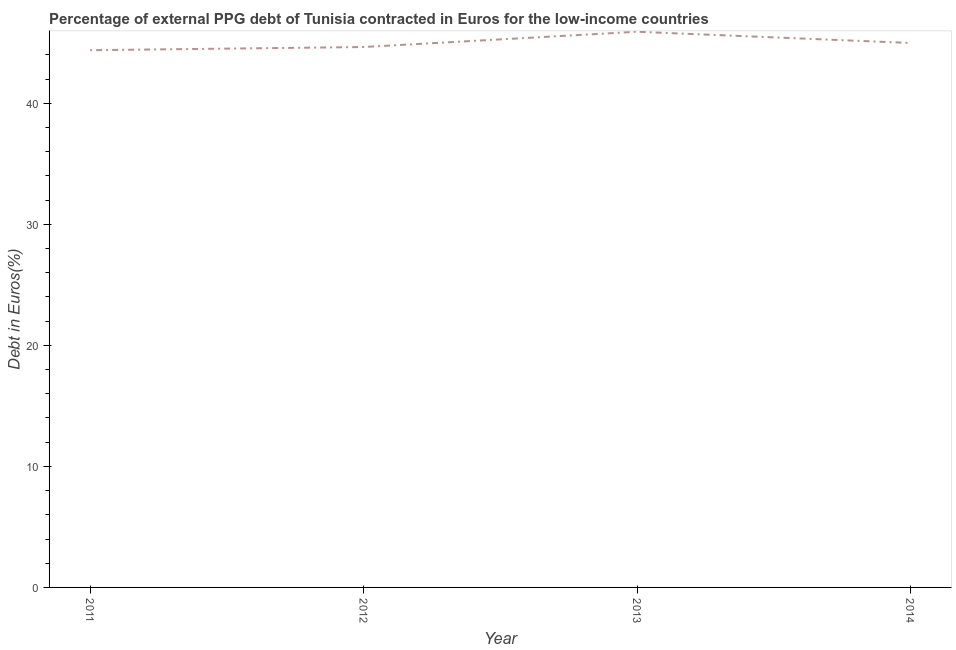What is the currency composition of ppg debt in 2014?
Offer a very short reply. 44.98. Across all years, what is the maximum currency composition of ppg debt?
Give a very brief answer. 45.91. Across all years, what is the minimum currency composition of ppg debt?
Offer a terse response. 44.39. What is the sum of the currency composition of ppg debt?
Make the answer very short. 179.93. What is the difference between the currency composition of ppg debt in 2012 and 2013?
Your answer should be very brief. -1.26. What is the average currency composition of ppg debt per year?
Offer a very short reply. 44.98. What is the median currency composition of ppg debt?
Your response must be concise. 44.82. In how many years, is the currency composition of ppg debt greater than 14 %?
Your response must be concise. 4. What is the ratio of the currency composition of ppg debt in 2012 to that in 2014?
Your answer should be very brief. 0.99. Is the currency composition of ppg debt in 2013 less than that in 2014?
Your answer should be very brief. No. Is the difference between the currency composition of ppg debt in 2012 and 2013 greater than the difference between any two years?
Keep it short and to the point. No. What is the difference between the highest and the second highest currency composition of ppg debt?
Offer a terse response. 0.93. What is the difference between the highest and the lowest currency composition of ppg debt?
Provide a short and direct response. 1.53. How many years are there in the graph?
Make the answer very short. 4. Are the values on the major ticks of Y-axis written in scientific E-notation?
Your answer should be very brief. No. Does the graph contain grids?
Ensure brevity in your answer.  No. What is the title of the graph?
Ensure brevity in your answer.  Percentage of external PPG debt of Tunisia contracted in Euros for the low-income countries. What is the label or title of the X-axis?
Give a very brief answer. Year. What is the label or title of the Y-axis?
Provide a short and direct response. Debt in Euros(%). What is the Debt in Euros(%) in 2011?
Offer a very short reply. 44.39. What is the Debt in Euros(%) of 2012?
Ensure brevity in your answer.  44.65. What is the Debt in Euros(%) of 2013?
Make the answer very short. 45.91. What is the Debt in Euros(%) of 2014?
Ensure brevity in your answer.  44.98. What is the difference between the Debt in Euros(%) in 2011 and 2012?
Keep it short and to the point. -0.26. What is the difference between the Debt in Euros(%) in 2011 and 2013?
Provide a succinct answer. -1.53. What is the difference between the Debt in Euros(%) in 2011 and 2014?
Offer a terse response. -0.6. What is the difference between the Debt in Euros(%) in 2012 and 2013?
Give a very brief answer. -1.26. What is the difference between the Debt in Euros(%) in 2012 and 2014?
Your answer should be compact. -0.33. What is the difference between the Debt in Euros(%) in 2013 and 2014?
Your response must be concise. 0.93. What is the ratio of the Debt in Euros(%) in 2011 to that in 2013?
Provide a short and direct response. 0.97. What is the ratio of the Debt in Euros(%) in 2012 to that in 2014?
Make the answer very short. 0.99. What is the ratio of the Debt in Euros(%) in 2013 to that in 2014?
Provide a short and direct response. 1.02. 